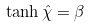Convert formula to latex. <formula><loc_0><loc_0><loc_500><loc_500>\tanh { \hat { \chi } } = \beta</formula> 